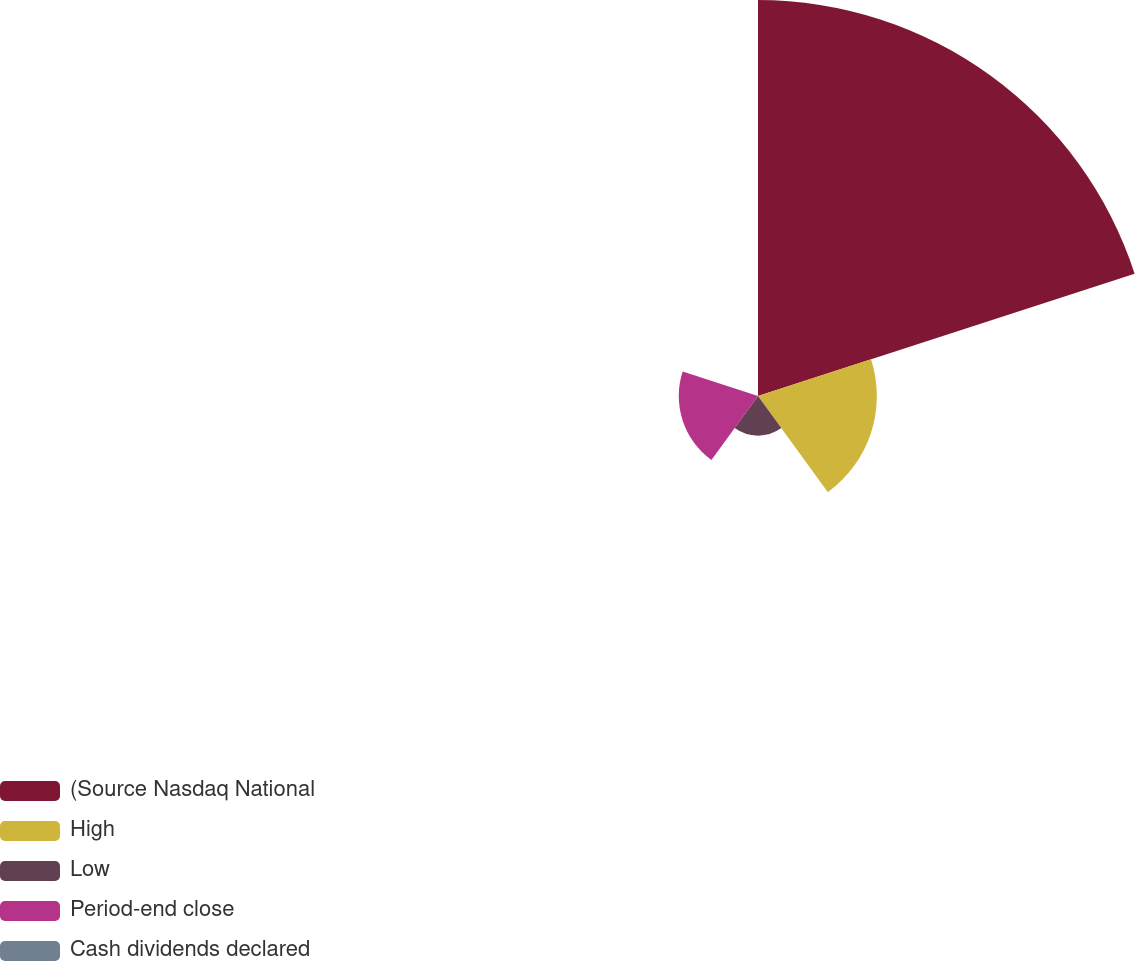Convert chart. <chart><loc_0><loc_0><loc_500><loc_500><pie_chart><fcel>(Source Nasdaq National<fcel>High<fcel>Low<fcel>Period-end close<fcel>Cash dividends declared<nl><fcel>62.48%<fcel>18.75%<fcel>6.26%<fcel>12.5%<fcel>0.01%<nl></chart> 